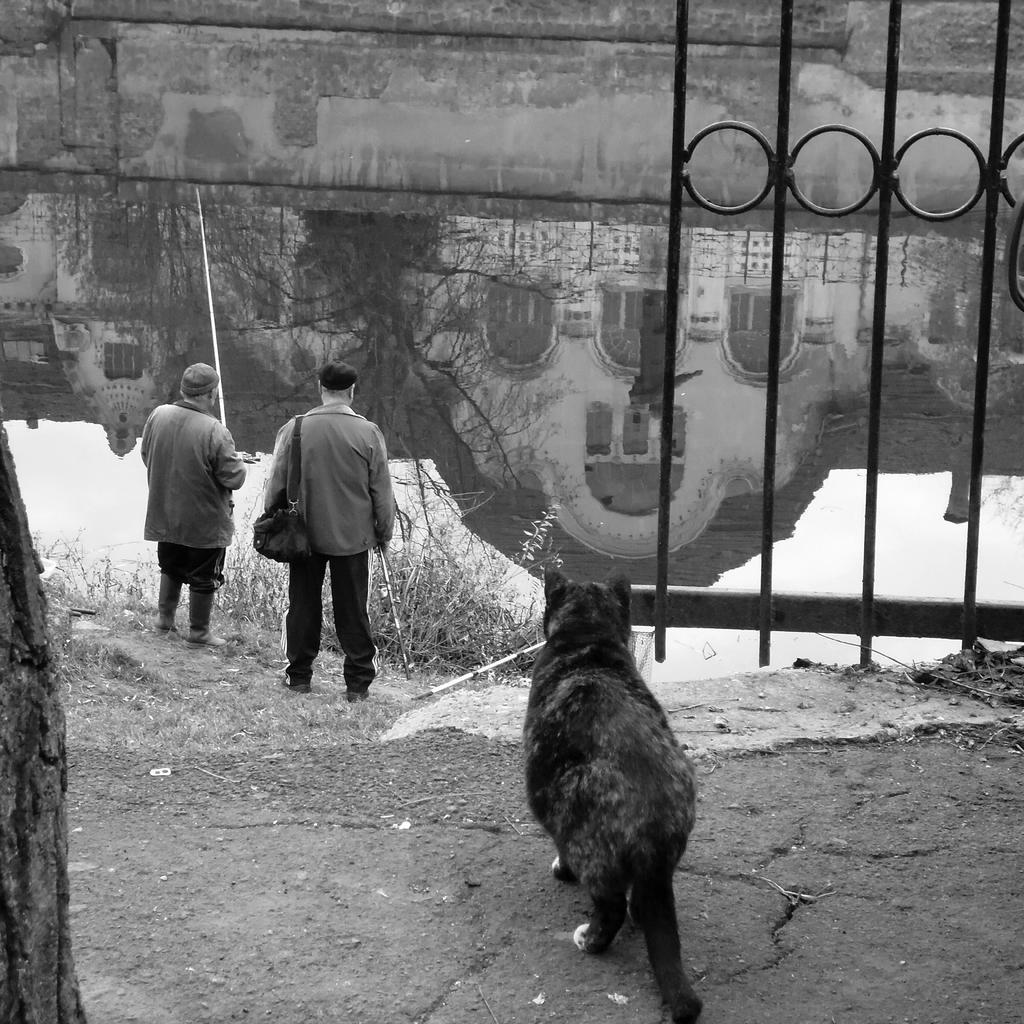Describe this image in one or two sentences. In this image I can see the black and white picture in which I can see an animal is standing on the ground, two persons standing, few trees, the metal gate and the water. On the surface of the water I can see the reflection of the building and the sky. 